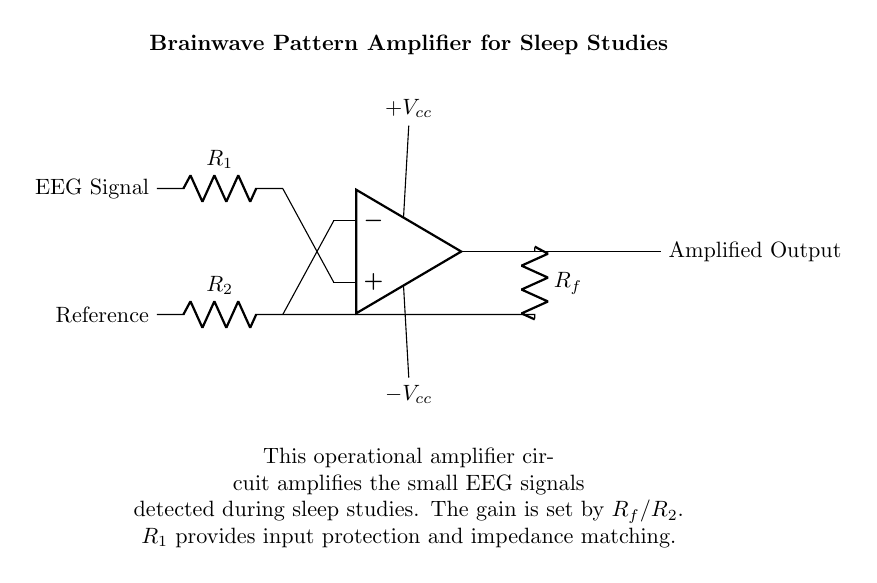What type of circuit is displayed? The circuit is an operational amplifier circuit, which is specifically used for amplifying weak signals, such as EEG signals in this case.
Answer: operational amplifier What is the purpose of resistor R1? Resistor R1 provides input protection and impedance matching for the EEG signals fed into the operational amplifier, ensuring that the input signal does not damage the op-amp and matches the input impedance appropriately.
Answer: input protection and impedance matching What does the amplified output signify? The amplified output represents the processed and enhanced EEG signal, which can be analyzed for brainwave patterns during sleep studies. This output is crucial for further analysis in sleep research.
Answer: processed EEG signal How is the gain of this amplifier determined? The gain of the amplifier is set by the ratio of the feedback resistor Rf to the resistor R2, which is reflected in the formula for gain in an inverting amplifier configuration (gain = Rf/R2).
Answer: Rf/R2 What are the supply voltages for the operational amplifier? The supply voltages for the operational amplifier are labeled as +Vcc and -Vcc, indicating positive and negative supply voltages necessary for the op-amp's operation.
Answer: +Vcc and -Vcc How are the inputs to the op-amp labeled? The inputs to the operational amplifier are labeled as the non-inverting input connected to the EEG signal and the inverting input connected to the reference signal, allowing the op-amp to process the difference between these two inputs.
Answer: EEG signal and Reference What role does Rf play in the circuit? Resistor Rf acts as the feedback resistor, which is critical for setting the gain of the operational amplifier circuit, directly influencing how much the input signal is amplified before reaching the output.
Answer: sets gain 